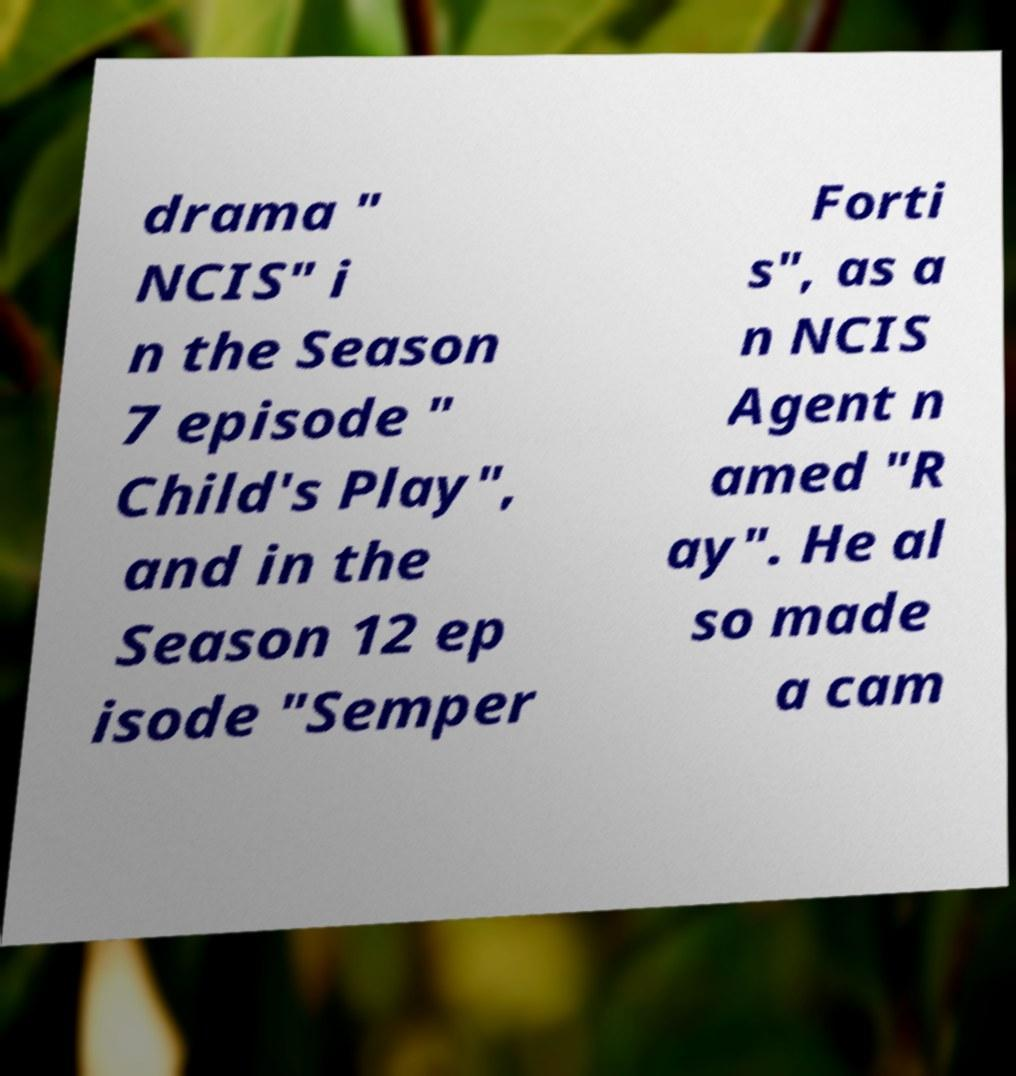Could you assist in decoding the text presented in this image and type it out clearly? drama " NCIS" i n the Season 7 episode " Child's Play", and in the Season 12 ep isode "Semper Forti s", as a n NCIS Agent n amed "R ay". He al so made a cam 